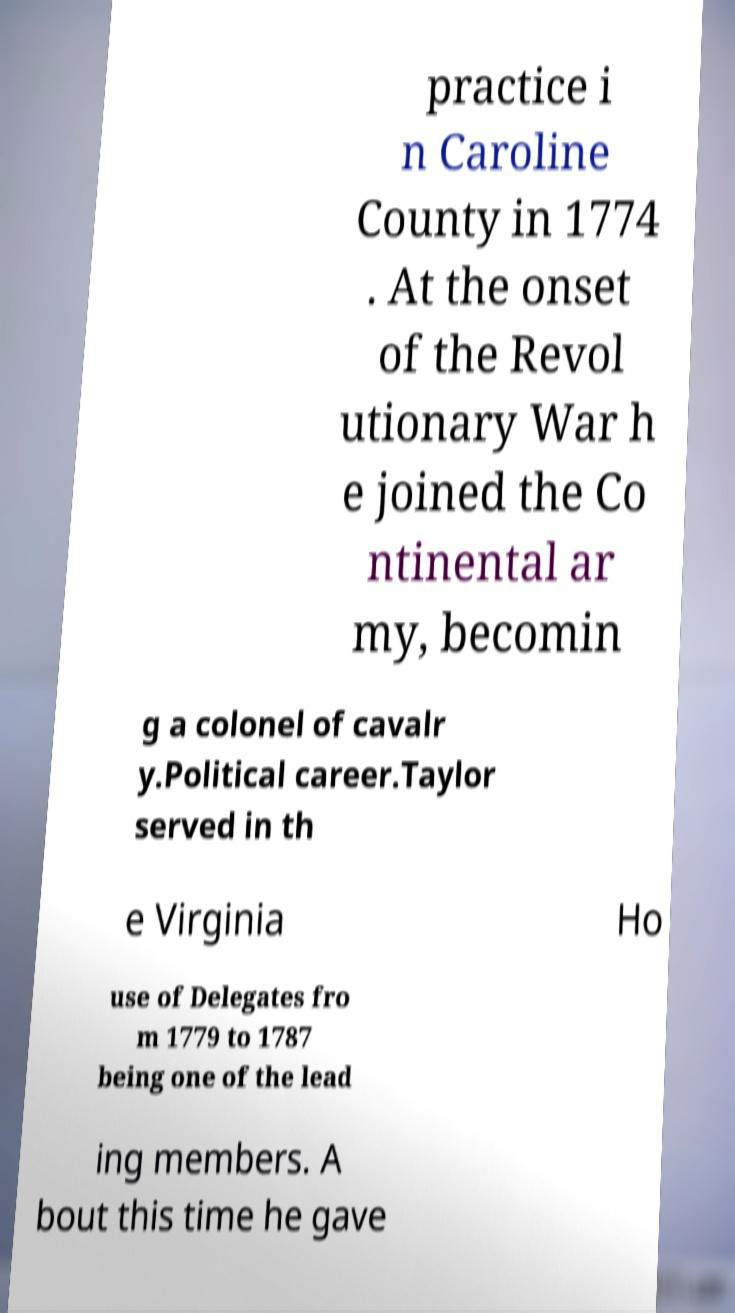For documentation purposes, I need the text within this image transcribed. Could you provide that? practice i n Caroline County in 1774 . At the onset of the Revol utionary War h e joined the Co ntinental ar my, becomin g a colonel of cavalr y.Political career.Taylor served in th e Virginia Ho use of Delegates fro m 1779 to 1787 being one of the lead ing members. A bout this time he gave 